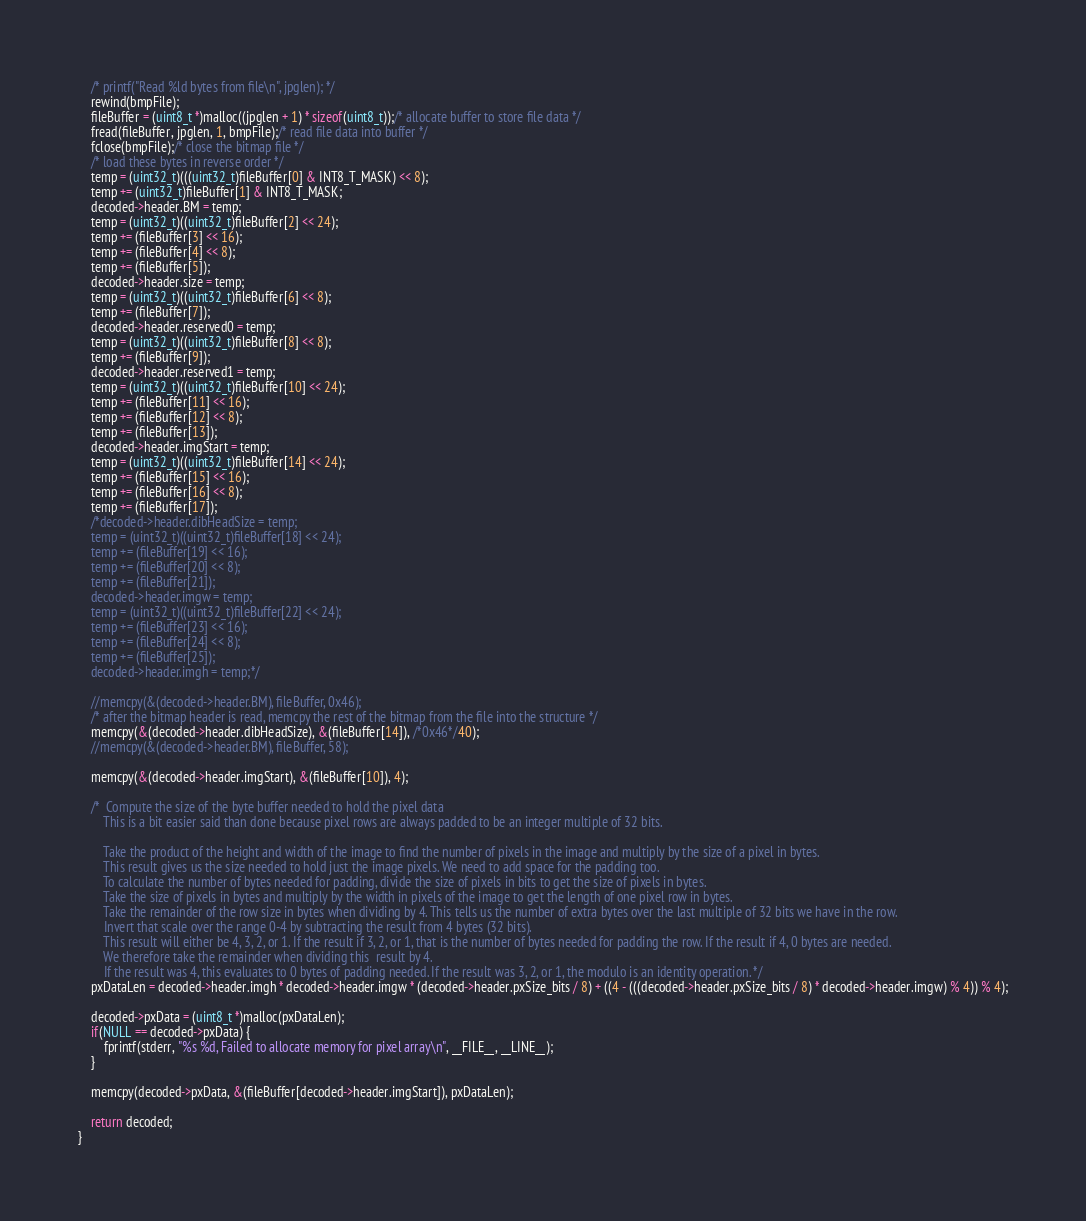<code> <loc_0><loc_0><loc_500><loc_500><_C_>	/* printf("Read %ld bytes from file\n", jpglen); */
	rewind(bmpFile);
	fileBuffer = (uint8_t *)malloc((jpglen + 1) * sizeof(uint8_t));/* allocate buffer to store file data */
	fread(fileBuffer, jpglen, 1, bmpFile);/* read file data into buffer */
	fclose(bmpFile);/* close the bitmap file */
	/* load these bytes in reverse order */
	temp = (uint32_t)(((uint32_t)fileBuffer[0] & INT8_T_MASK) << 8);
	temp += (uint32_t)fileBuffer[1] & INT8_T_MASK;
	decoded->header.BM = temp;
	temp = (uint32_t)((uint32_t)fileBuffer[2] << 24);
	temp += (fileBuffer[3] << 16);
	temp += (fileBuffer[4] << 8);
	temp += (fileBuffer[5]);
	decoded->header.size = temp;
	temp = (uint32_t)((uint32_t)fileBuffer[6] << 8);
	temp += (fileBuffer[7]);
	decoded->header.reserved0 = temp;
	temp = (uint32_t)((uint32_t)fileBuffer[8] << 8);
	temp += (fileBuffer[9]);
	decoded->header.reserved1 = temp;
	temp = (uint32_t)((uint32_t)fileBuffer[10] << 24);
	temp += (fileBuffer[11] << 16);
	temp += (fileBuffer[12] << 8);
	temp += (fileBuffer[13]);
	decoded->header.imgStart = temp;
	temp = (uint32_t)((uint32_t)fileBuffer[14] << 24);
	temp += (fileBuffer[15] << 16);
	temp += (fileBuffer[16] << 8);
	temp += (fileBuffer[17]);
	/*decoded->header.dibHeadSize = temp;
	temp = (uint32_t)((uint32_t)fileBuffer[18] << 24);
	temp += (fileBuffer[19] << 16);
	temp += (fileBuffer[20] << 8);
	temp += (fileBuffer[21]);
	decoded->header.imgw = temp;
	temp = (uint32_t)((uint32_t)fileBuffer[22] << 24);
	temp += (fileBuffer[23] << 16);
	temp += (fileBuffer[24] << 8);
	temp += (fileBuffer[25]);
	decoded->header.imgh = temp;*/

	//memcpy(&(decoded->header.BM), fileBuffer, 0x46);
	/* after the bitmap header is read, memcpy the rest of the bitmap from the file into the structure */
	memcpy(&(decoded->header.dibHeadSize), &(fileBuffer[14]), /*0x46*/40);
	//memcpy(&(decoded->header.BM), fileBuffer, 58);

	memcpy(&(decoded->header.imgStart), &(fileBuffer[10]), 4);

	/*  Compute the size of the byte buffer needed to hold the pixel data
	    This is a bit easier said than done because pixel rows are always padded to be an integer multiple of 32 bits.

		Take the product of the height and width of the image to find the number of pixels in the image and multiply by the size of a pixel in bytes.
		This result gives us the size needed to hold just the image pixels. We need to add space for the padding too.
		To calculate the number of bytes needed for padding, divide the size of pixels in bits to get the size of pixels in bytes.
		Take the size of pixels in bytes and multiply by the width in pixels of the image to get the length of one pixel row in bytes.
		Take the remainder of the row size in bytes when dividing by 4. This tells us the number of extra bytes over the last multiple of 32 bits we have in the row.
		Invert that scale over the range 0-4 by subtracting the result from 4 bytes (32 bits).
		This result will either be 4, 3, 2, or 1. If the result if 3, 2, or 1, that is the number of bytes needed for padding the row. If the result if 4, 0 bytes are needed.
		We therefore take the remainder when dividing this  result by 4.
		If the result was 4, this evaluates to 0 bytes of padding needed. If the result was 3, 2, or 1, the modulo is an identity operation. */
	pxDataLen = decoded->header.imgh * decoded->header.imgw * (decoded->header.pxSize_bits / 8) + ((4 - (((decoded->header.pxSize_bits / 8) * decoded->header.imgw) % 4)) % 4);

	decoded->pxData = (uint8_t *)malloc(pxDataLen);
	if(NULL == decoded->pxData) {
		fprintf(stderr, "%s %d, Failed to allocate memory for pixel array\n", __FILE__, __LINE__);
	}
	
	memcpy(decoded->pxData, &(fileBuffer[decoded->header.imgStart]), pxDataLen);

	return decoded;
}
</code> 